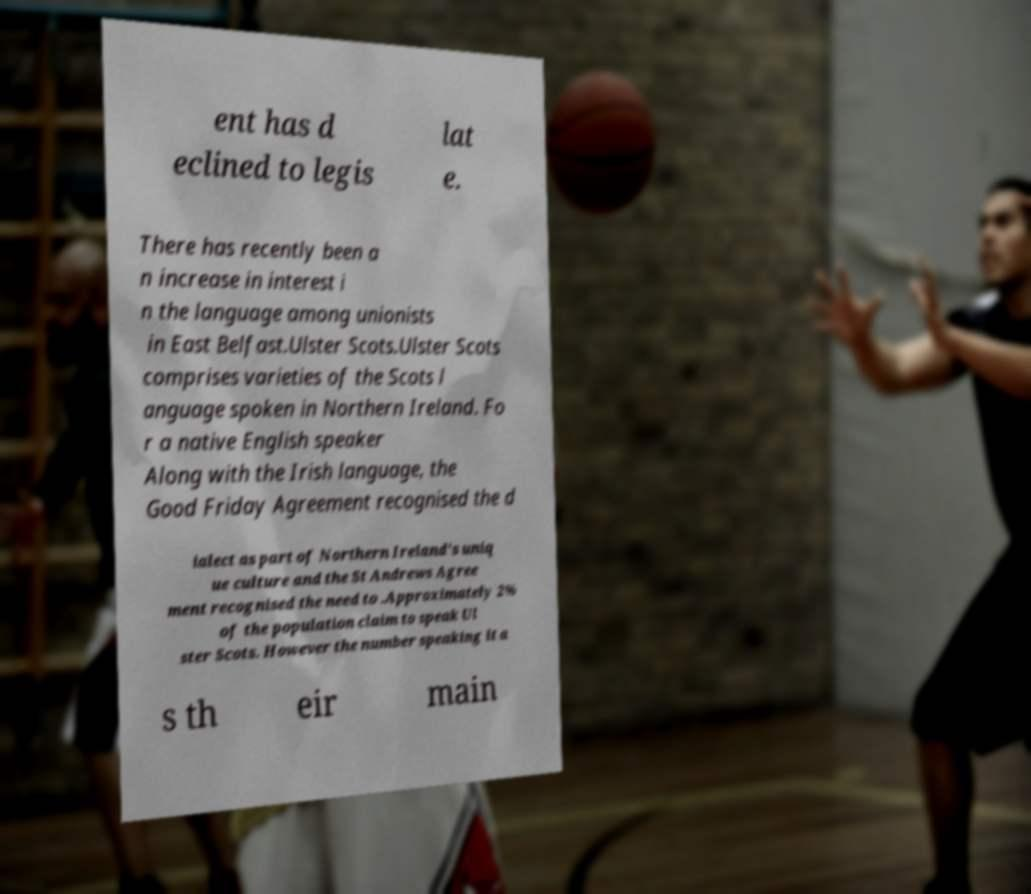Could you extract and type out the text from this image? ent has d eclined to legis lat e. There has recently been a n increase in interest i n the language among unionists in East Belfast.Ulster Scots.Ulster Scots comprises varieties of the Scots l anguage spoken in Northern Ireland. Fo r a native English speaker Along with the Irish language, the Good Friday Agreement recognised the d ialect as part of Northern Ireland's uniq ue culture and the St Andrews Agree ment recognised the need to .Approximately 2% of the population claim to speak Ul ster Scots. However the number speaking it a s th eir main 